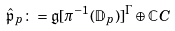Convert formula to latex. <formula><loc_0><loc_0><loc_500><loc_500>\hat { \mathfrak { p } } _ { p } \colon = \mathfrak { g } [ \pi ^ { - 1 } ( \mathbb { D } _ { p } ) ] ^ { \Gamma } \oplus \mathbb { C } C</formula> 